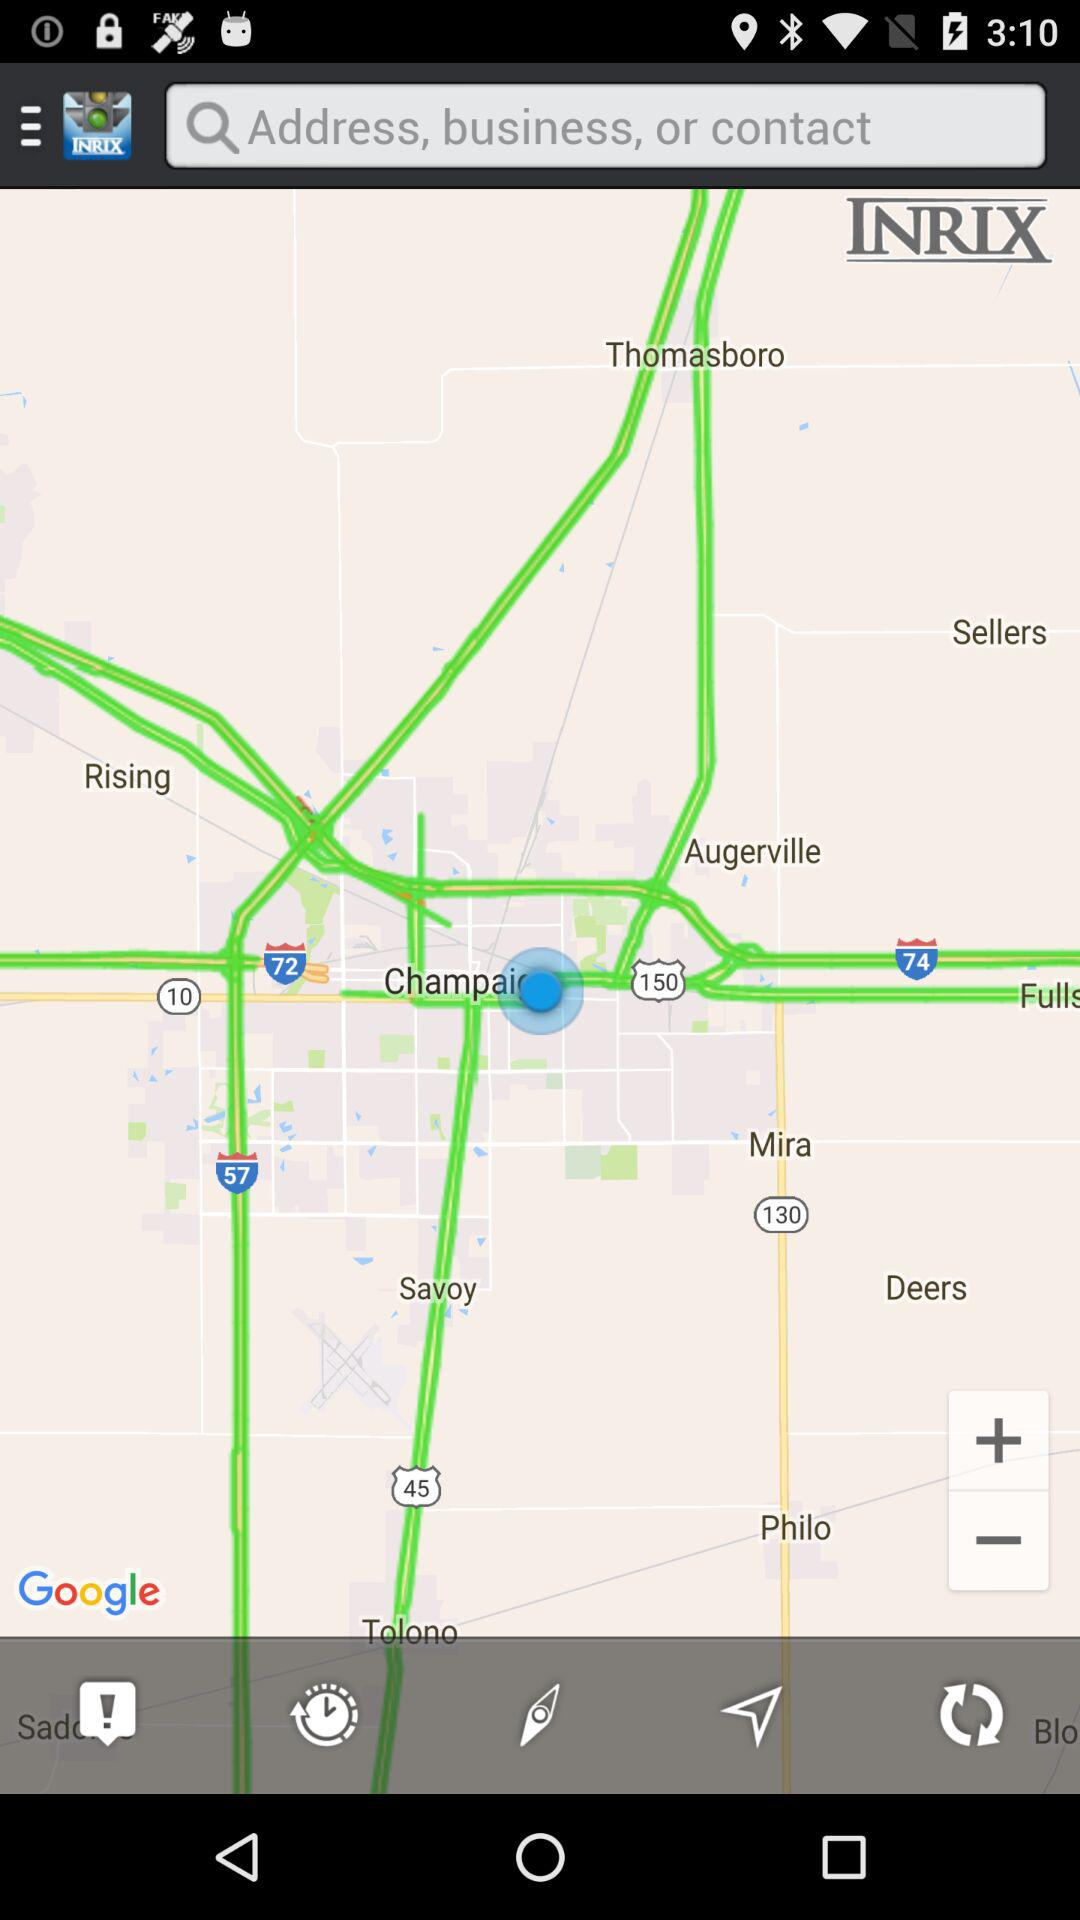What is the name of the application? The name of the application is "INRIX". 